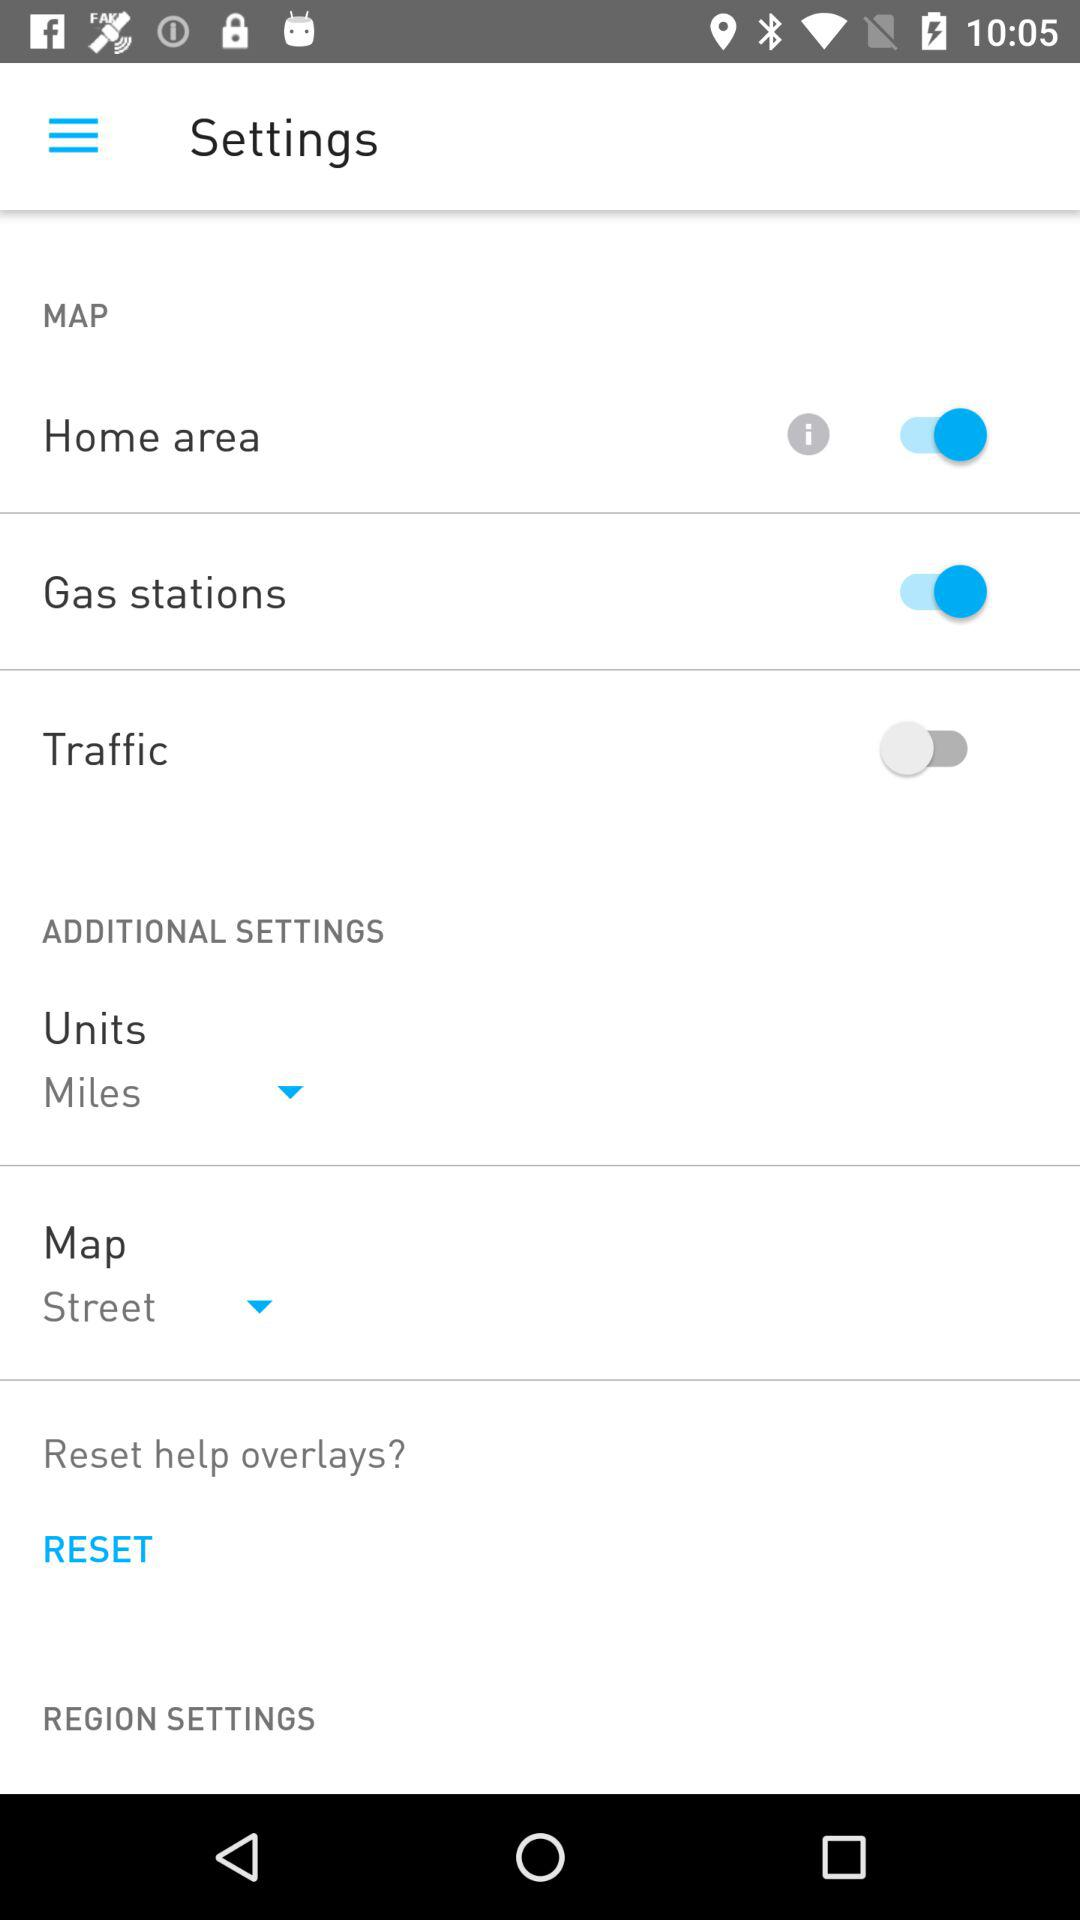Which settings have the status "on"? The settings that have the status "on" are "Home area" and "Gas stations". 